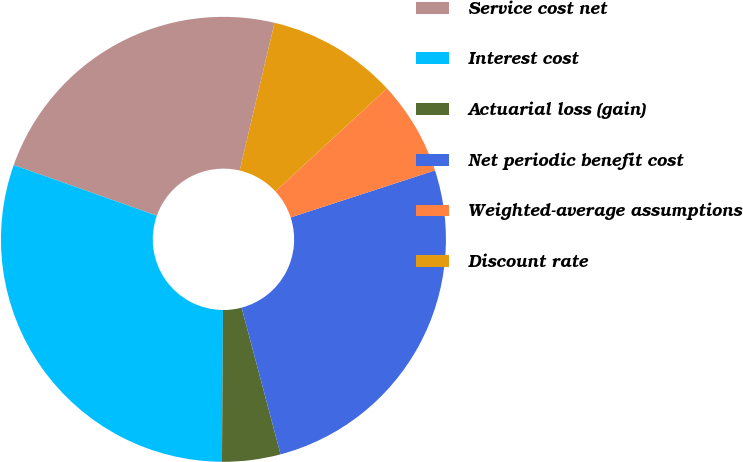Convert chart. <chart><loc_0><loc_0><loc_500><loc_500><pie_chart><fcel>Service cost net<fcel>Interest cost<fcel>Actuarial loss (gain)<fcel>Net periodic benefit cost<fcel>Weighted-average assumptions<fcel>Discount rate<nl><fcel>23.27%<fcel>30.31%<fcel>4.24%<fcel>25.88%<fcel>6.85%<fcel>9.45%<nl></chart> 